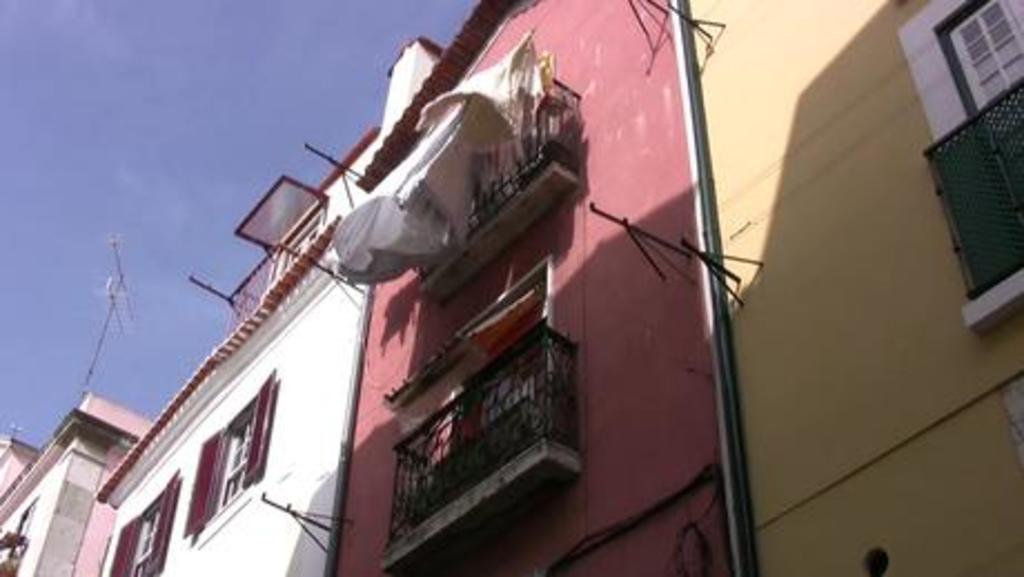Please provide a concise description of this image. This picture is clicked outside. In the foreground we can see the buildings windows, deck rails, walls of the buildings and we can see the metal rods and the sky. 